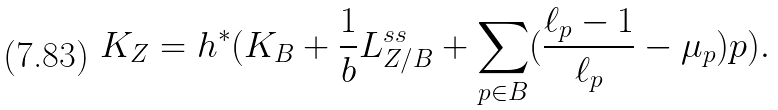Convert formula to latex. <formula><loc_0><loc_0><loc_500><loc_500>K _ { Z } = h ^ { \ast } ( K _ { B } + \frac { 1 } { b } L ^ { s s } _ { Z / B } + \sum _ { p \in B } ( \frac { \ell _ { p } - 1 } { \ell _ { p } } - \mu _ { p } ) p ) .</formula> 